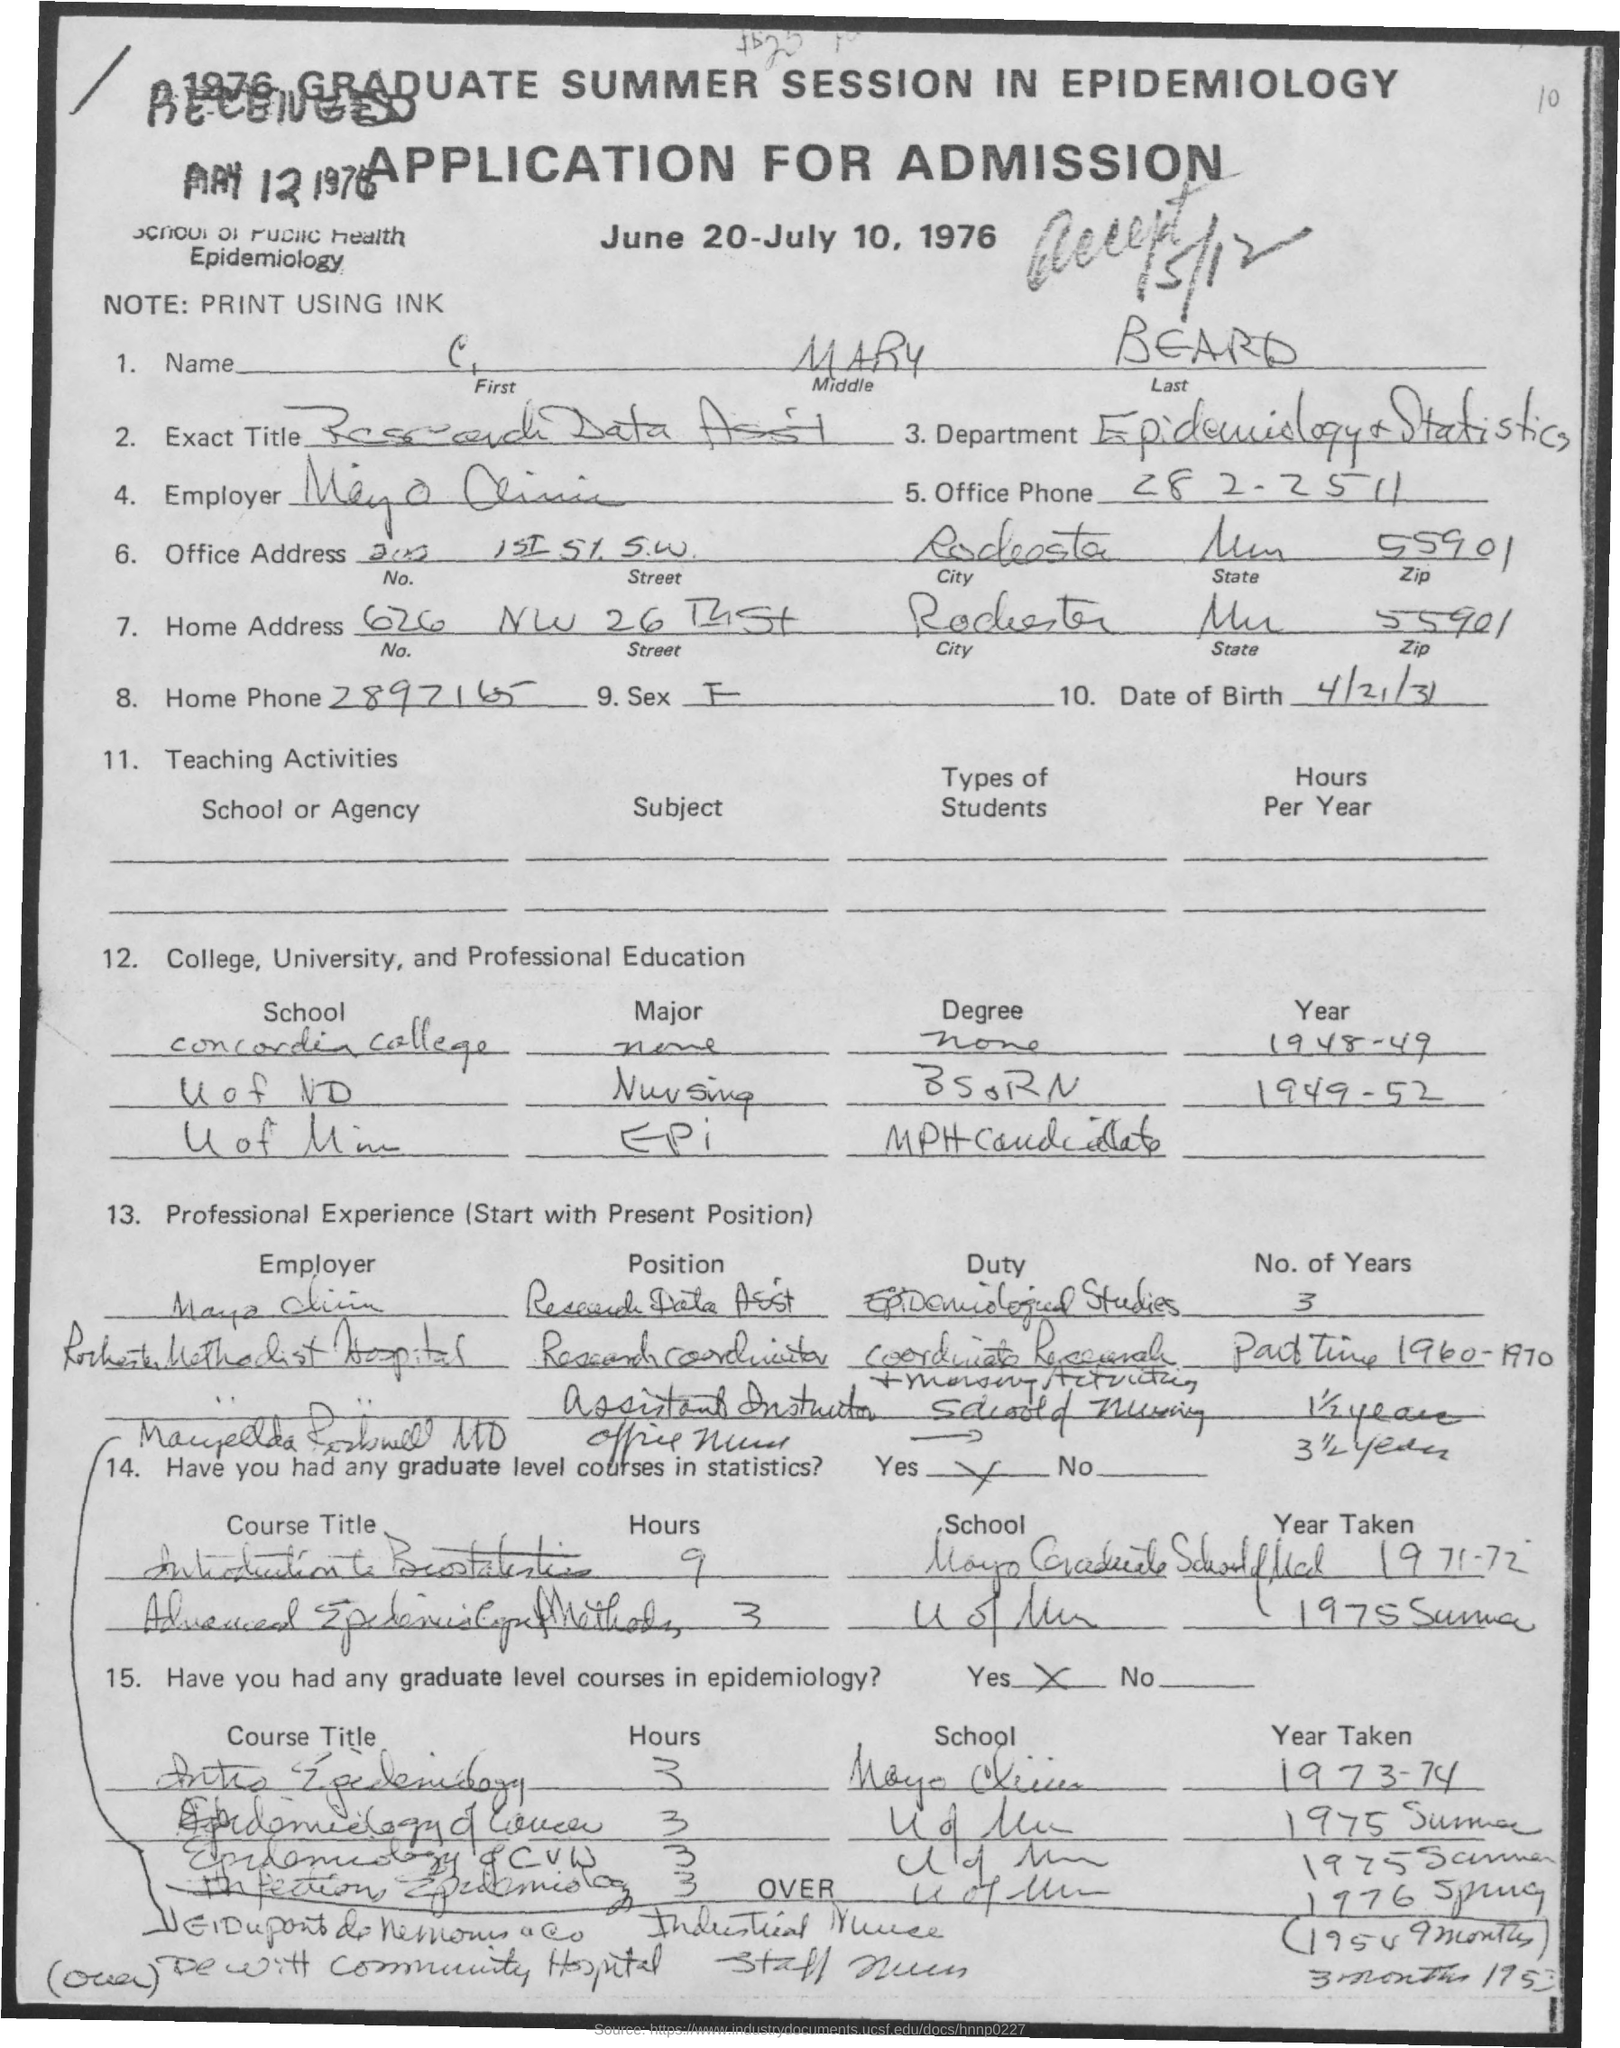What is the name of the department ?
Your answer should be very brief. Epidemiology + Statistics. What is the office phone number ?
Provide a short and direct response. 282-2511. What is the zip code of address ?
Provide a succinct answer. 55901. 